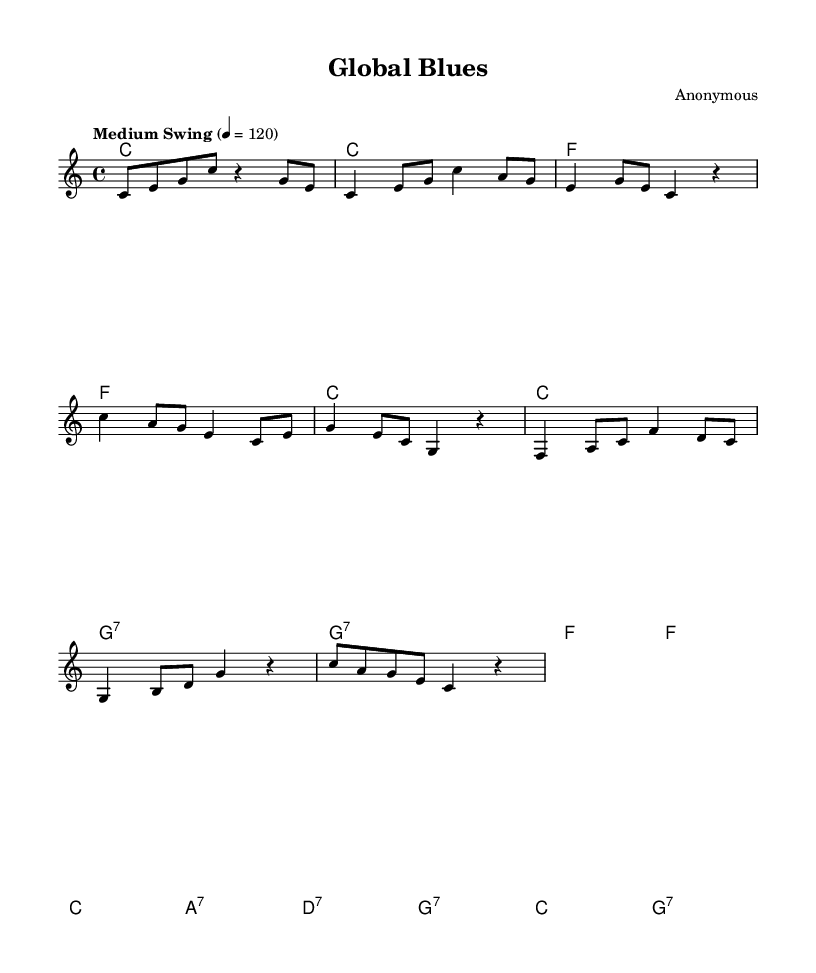What is the key signature of this music? The key signature is indicated as C major, which is represented with no sharps or flats at the beginning of the staff.
Answer: C major What is the time signature of this music? The time signature is indicated as 4/4, which is commonly found in the rhythmic structure shown on the sheet.
Answer: 4/4 What is the tempo marking of this piece? The tempo marking is labeled as "Medium Swing," indicating a specific style and feel appropriate for jazz music.
Answer: Medium Swing How many measures are in the chorus section? The chorus consists of 4 measures, clearly outlined in the structure under the melody part.
Answer: 4 What is the first chord in the piece? The first chord indicated in the notation is a C major chord, as shown at the beginning of the chord layout.
Answer: C Which section follows the verse in the song structure? The section that follows the verse is the chorus, which is indicated after the lyrics for the verse.
Answer: Chorus How many notes are there in the bridge section? The bridge section contains a total of 8 notes, as counted when looking at the melody notation provided.
Answer: 8 